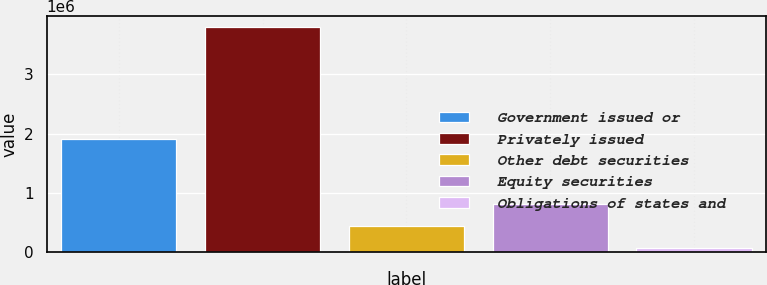Convert chart to OTSL. <chart><loc_0><loc_0><loc_500><loc_500><bar_chart><fcel>Government issued or<fcel>Privately issued<fcel>Other debt securities<fcel>Equity securities<fcel>Obligations of states and<nl><fcel>1.90771e+06<fcel>3.79653e+06<fcel>434792<fcel>808319<fcel>61266<nl></chart> 